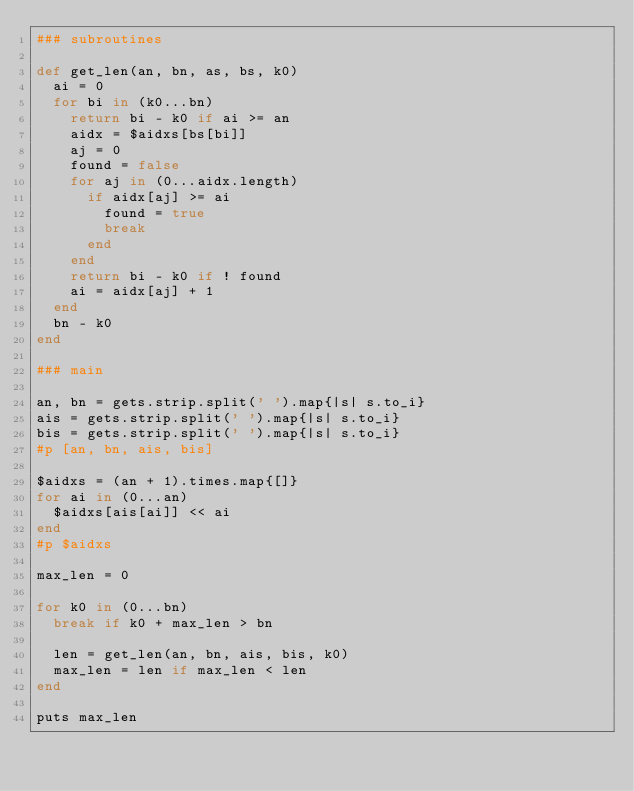<code> <loc_0><loc_0><loc_500><loc_500><_Ruby_>### subroutines

def get_len(an, bn, as, bs, k0)
  ai = 0
  for bi in (k0...bn)
    return bi - k0 if ai >= an
    aidx = $aidxs[bs[bi]]
    aj = 0
    found = false
    for aj in (0...aidx.length)
      if aidx[aj] >= ai
        found = true
        break
      end
    end
    return bi - k0 if ! found
    ai = aidx[aj] + 1
  end
  bn - k0
end

### main

an, bn = gets.strip.split(' ').map{|s| s.to_i}
ais = gets.strip.split(' ').map{|s| s.to_i}
bis = gets.strip.split(' ').map{|s| s.to_i}
#p [an, bn, ais, bis]

$aidxs = (an + 1).times.map{[]}
for ai in (0...an)
  $aidxs[ais[ai]] << ai
end
#p $aidxs

max_len = 0

for k0 in (0...bn)
  break if k0 + max_len > bn

  len = get_len(an, bn, ais, bis, k0)
  max_len = len if max_len < len
end

puts max_len</code> 